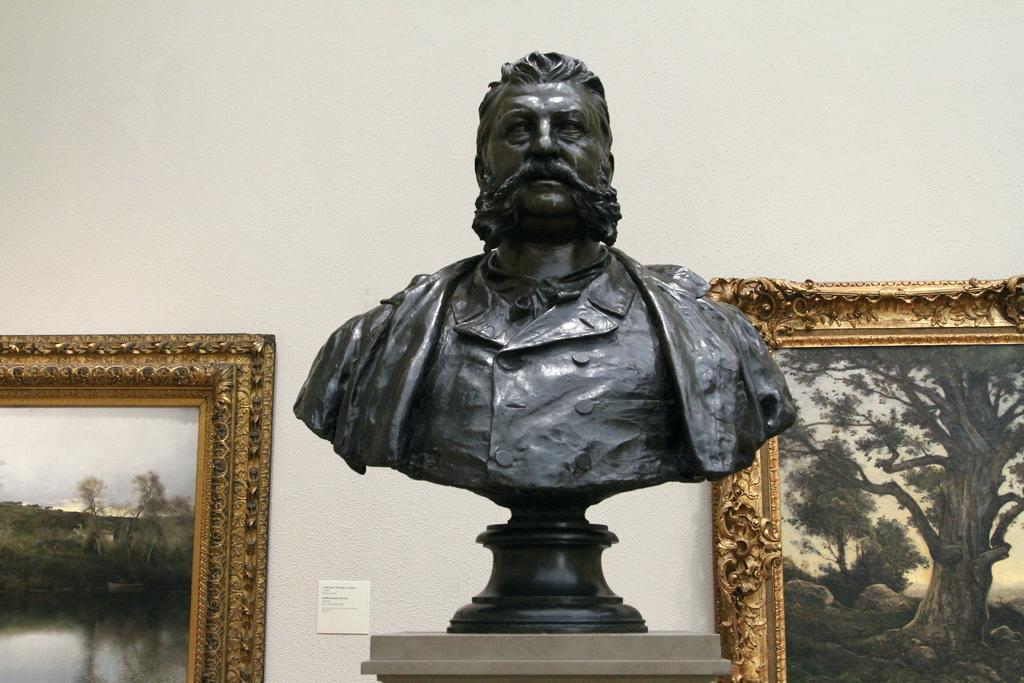What is the main subject of the image? The main subject of the image is a sculpture on a stand. Are there any other decorative elements in the image? Yes, there are wall hangings attached to the wall in the image. How many brothers are sitting in the boat in the image? There is no boat or brothers present in the image. 